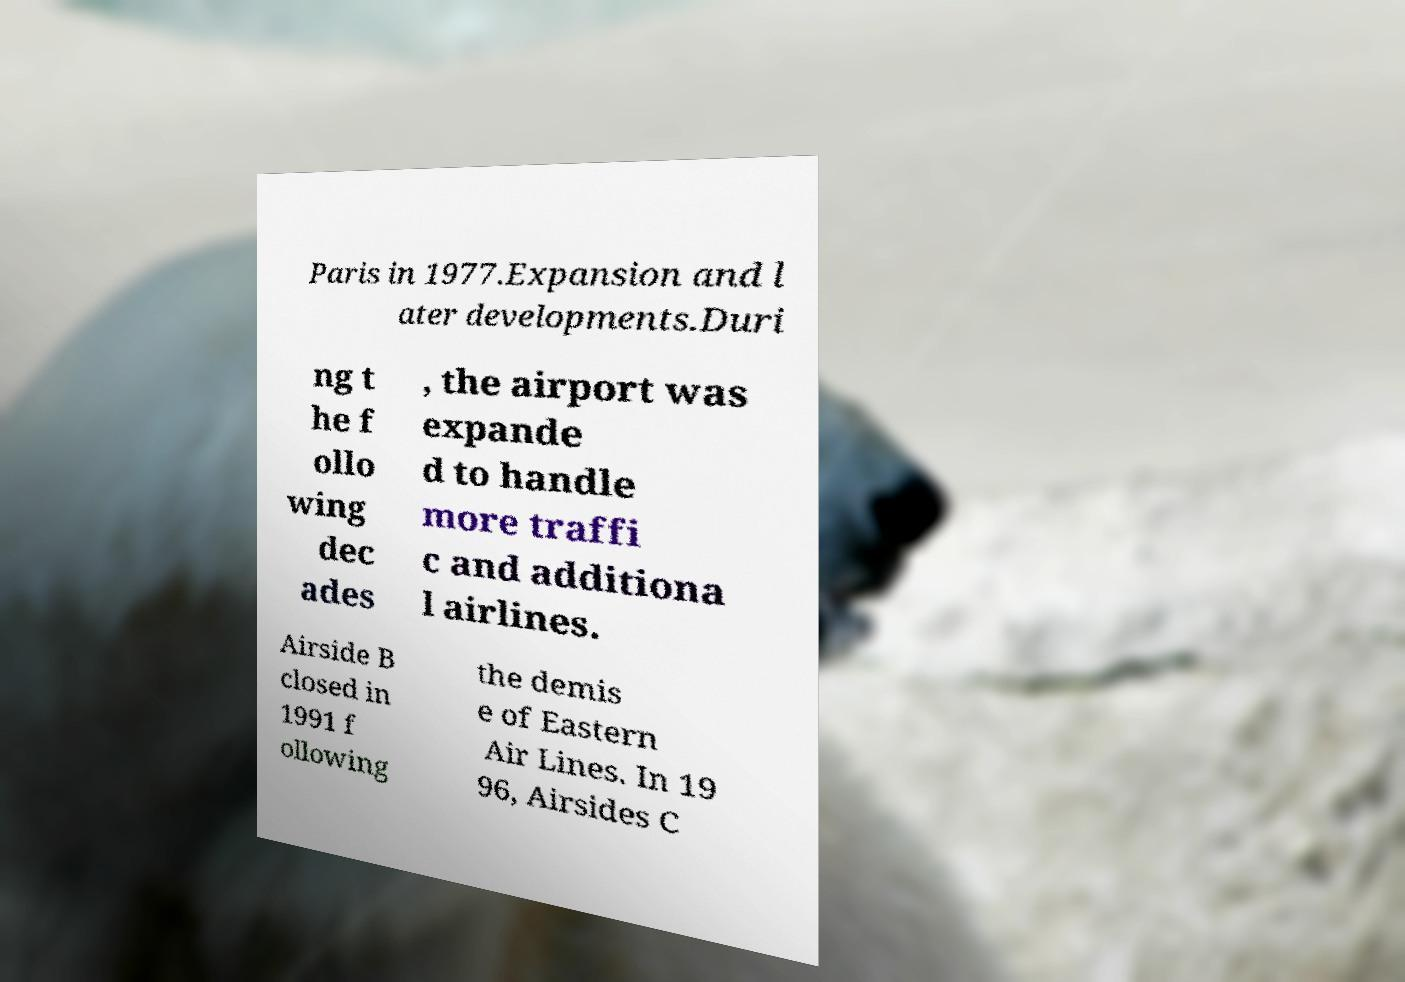I need the written content from this picture converted into text. Can you do that? Paris in 1977.Expansion and l ater developments.Duri ng t he f ollo wing dec ades , the airport was expande d to handle more traffi c and additiona l airlines. Airside B closed in 1991 f ollowing the demis e of Eastern Air Lines. In 19 96, Airsides C 